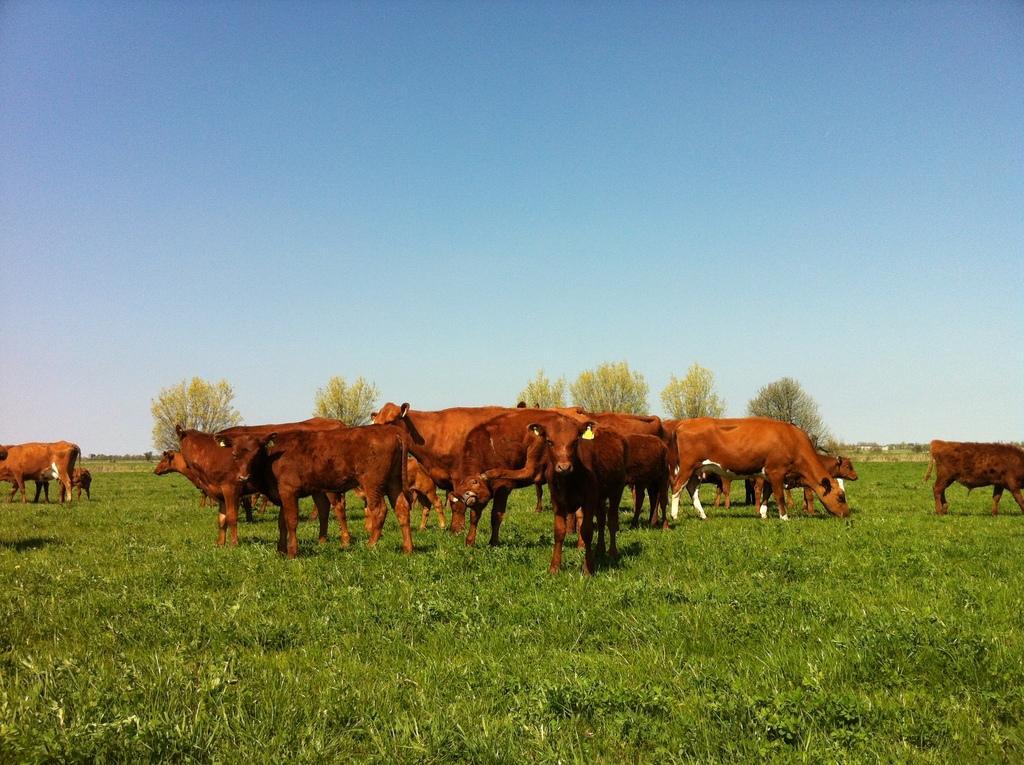Please provide a concise description of this image. This image is taken outdoors. At the top of the image there is a sky. At the bottom of the image there is a ground with grass on it. In the background there are a few trees and plants. In the middle of the image there are a few cattle grazing grass on the ground. 